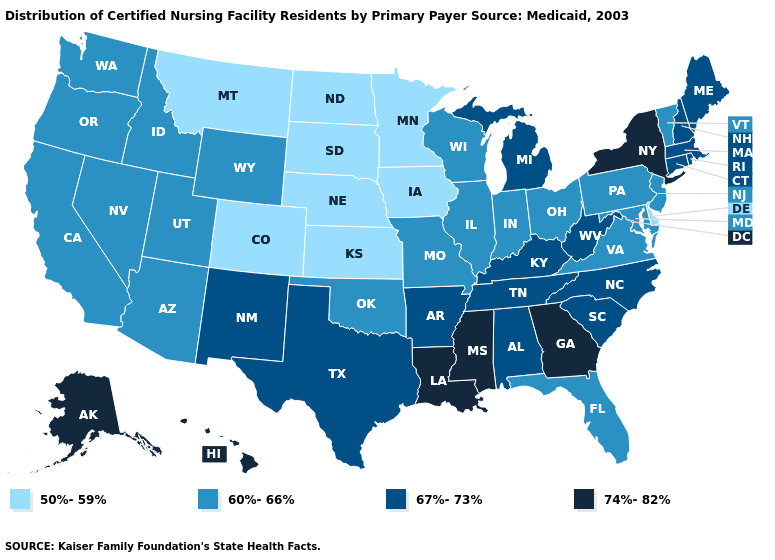Which states have the lowest value in the MidWest?
Short answer required. Iowa, Kansas, Minnesota, Nebraska, North Dakota, South Dakota. What is the value of Arkansas?
Give a very brief answer. 67%-73%. Which states have the highest value in the USA?
Answer briefly. Alaska, Georgia, Hawaii, Louisiana, Mississippi, New York. Does the map have missing data?
Quick response, please. No. What is the highest value in the MidWest ?
Write a very short answer. 67%-73%. Does Georgia have the highest value in the USA?
Keep it brief. Yes. Name the states that have a value in the range 67%-73%?
Answer briefly. Alabama, Arkansas, Connecticut, Kentucky, Maine, Massachusetts, Michigan, New Hampshire, New Mexico, North Carolina, Rhode Island, South Carolina, Tennessee, Texas, West Virginia. What is the value of Indiana?
Write a very short answer. 60%-66%. Does the map have missing data?
Short answer required. No. Does Wyoming have the highest value in the West?
Write a very short answer. No. What is the value of Nebraska?
Give a very brief answer. 50%-59%. What is the value of Washington?
Be succinct. 60%-66%. What is the lowest value in the USA?
Write a very short answer. 50%-59%. Among the states that border Utah , which have the lowest value?
Keep it brief. Colorado. Name the states that have a value in the range 50%-59%?
Quick response, please. Colorado, Delaware, Iowa, Kansas, Minnesota, Montana, Nebraska, North Dakota, South Dakota. 